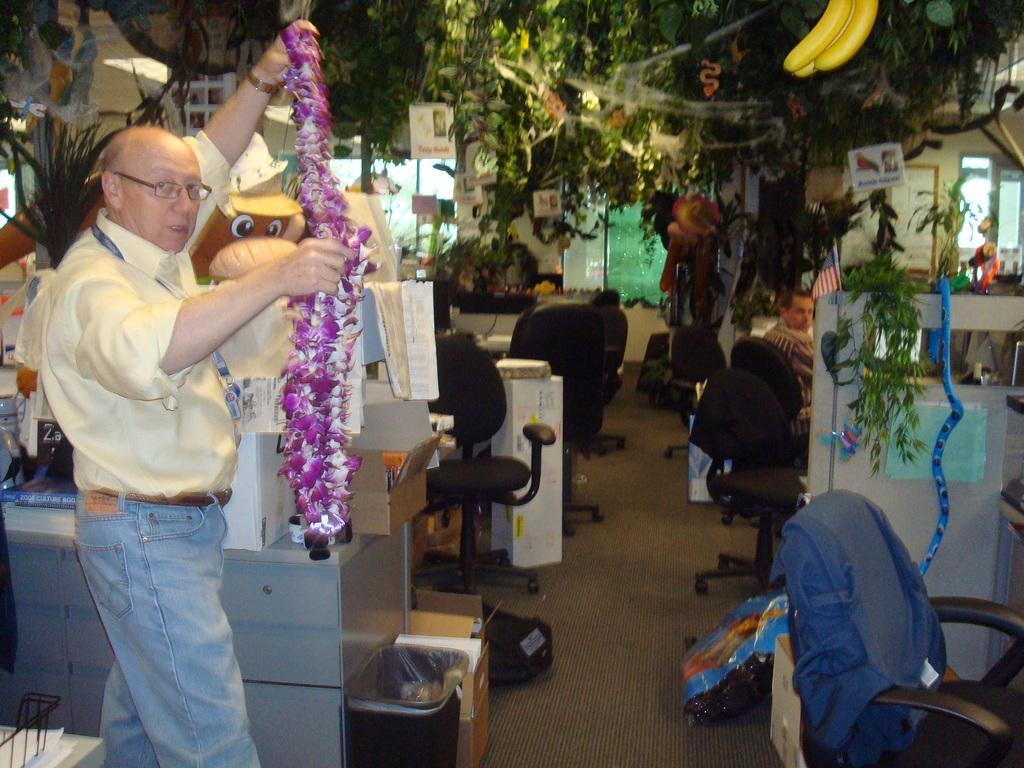Please provide a concise description of this image. On the left side, there is a person holding a garland. On the right side, there is a chair arranged. In the background, there are plants, there is a person sitting, there is a flag, there are chairs arranged, there are windows and other objects. 